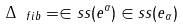Convert formula to latex. <formula><loc_0><loc_0><loc_500><loc_500>\Delta _ { \ f i b } = \in s s ( e ^ { \alpha } ) \in s s ( e _ { \alpha } )</formula> 